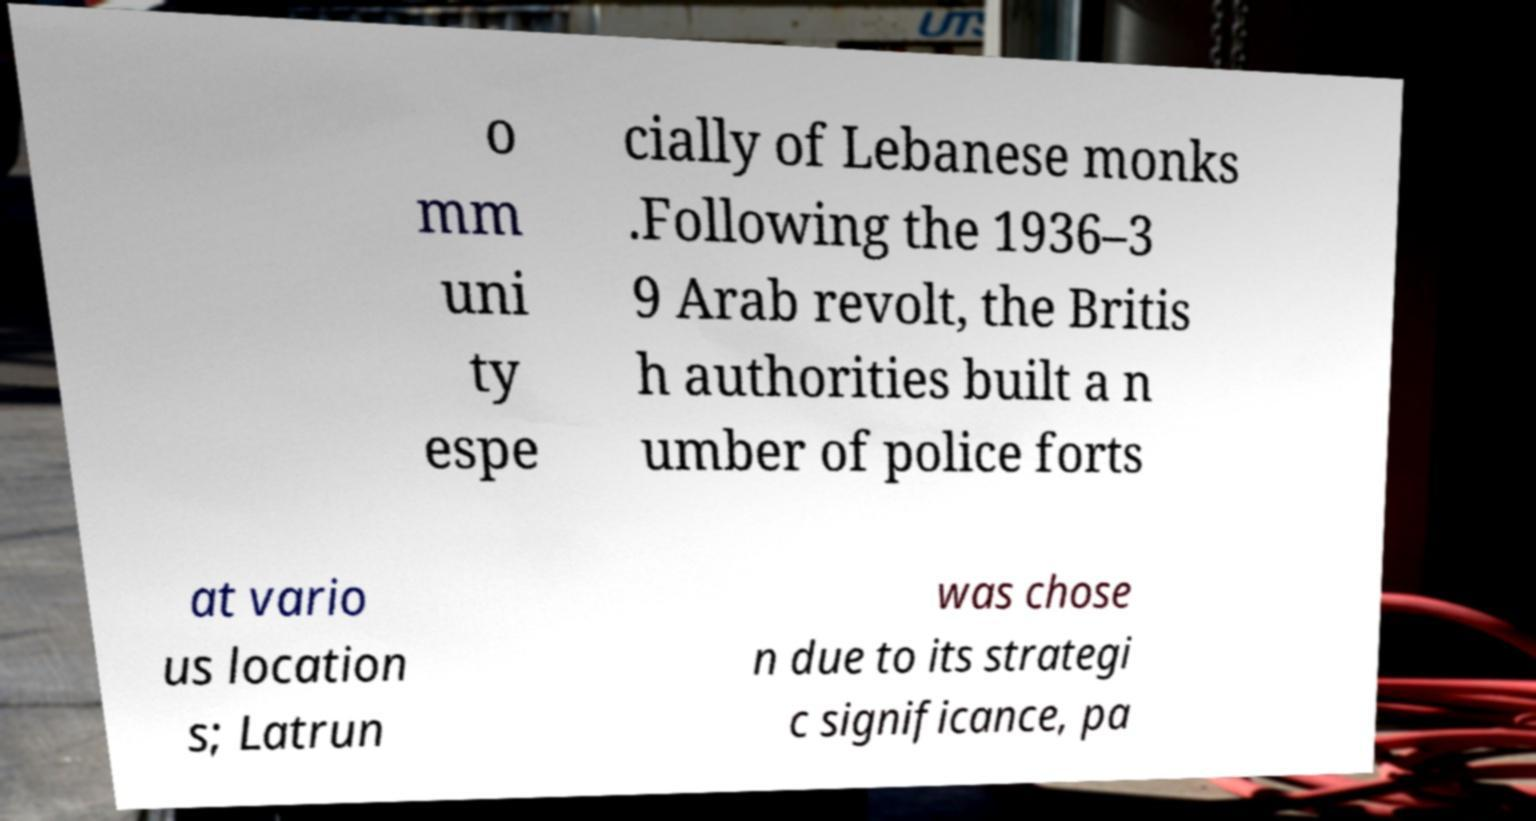Please identify and transcribe the text found in this image. o mm uni ty espe cially of Lebanese monks .Following the 1936–3 9 Arab revolt, the Britis h authorities built a n umber of police forts at vario us location s; Latrun was chose n due to its strategi c significance, pa 